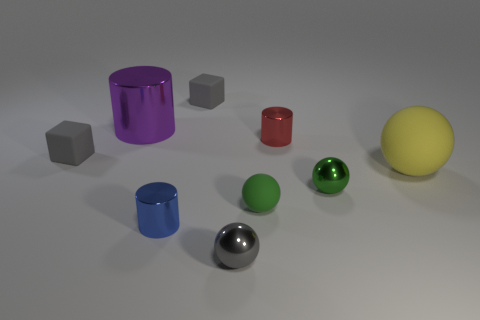Subtract all cubes. How many objects are left? 7 Subtract 0 cyan cubes. How many objects are left? 9 Subtract all large cyan blocks. Subtract all gray cubes. How many objects are left? 7 Add 2 red metallic cylinders. How many red metallic cylinders are left? 3 Add 1 red shiny cylinders. How many red shiny cylinders exist? 2 